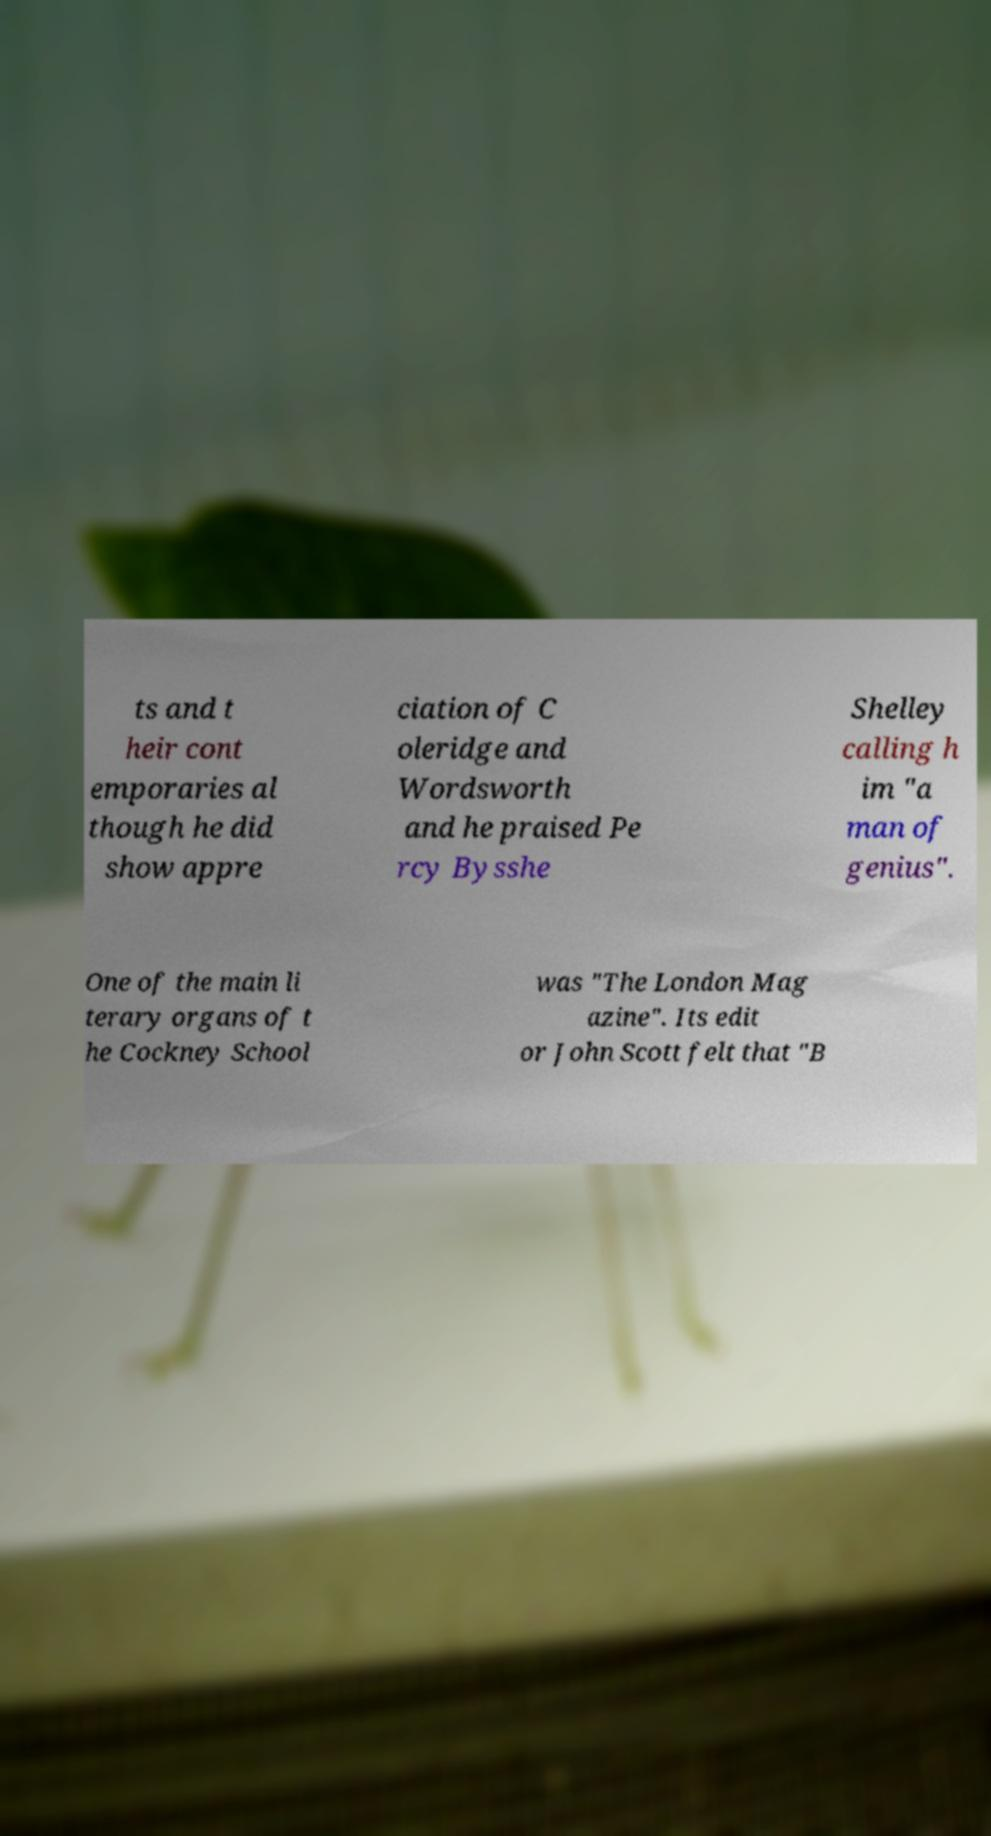Could you extract and type out the text from this image? ts and t heir cont emporaries al though he did show appre ciation of C oleridge and Wordsworth and he praised Pe rcy Bysshe Shelley calling h im "a man of genius". One of the main li terary organs of t he Cockney School was "The London Mag azine". Its edit or John Scott felt that "B 